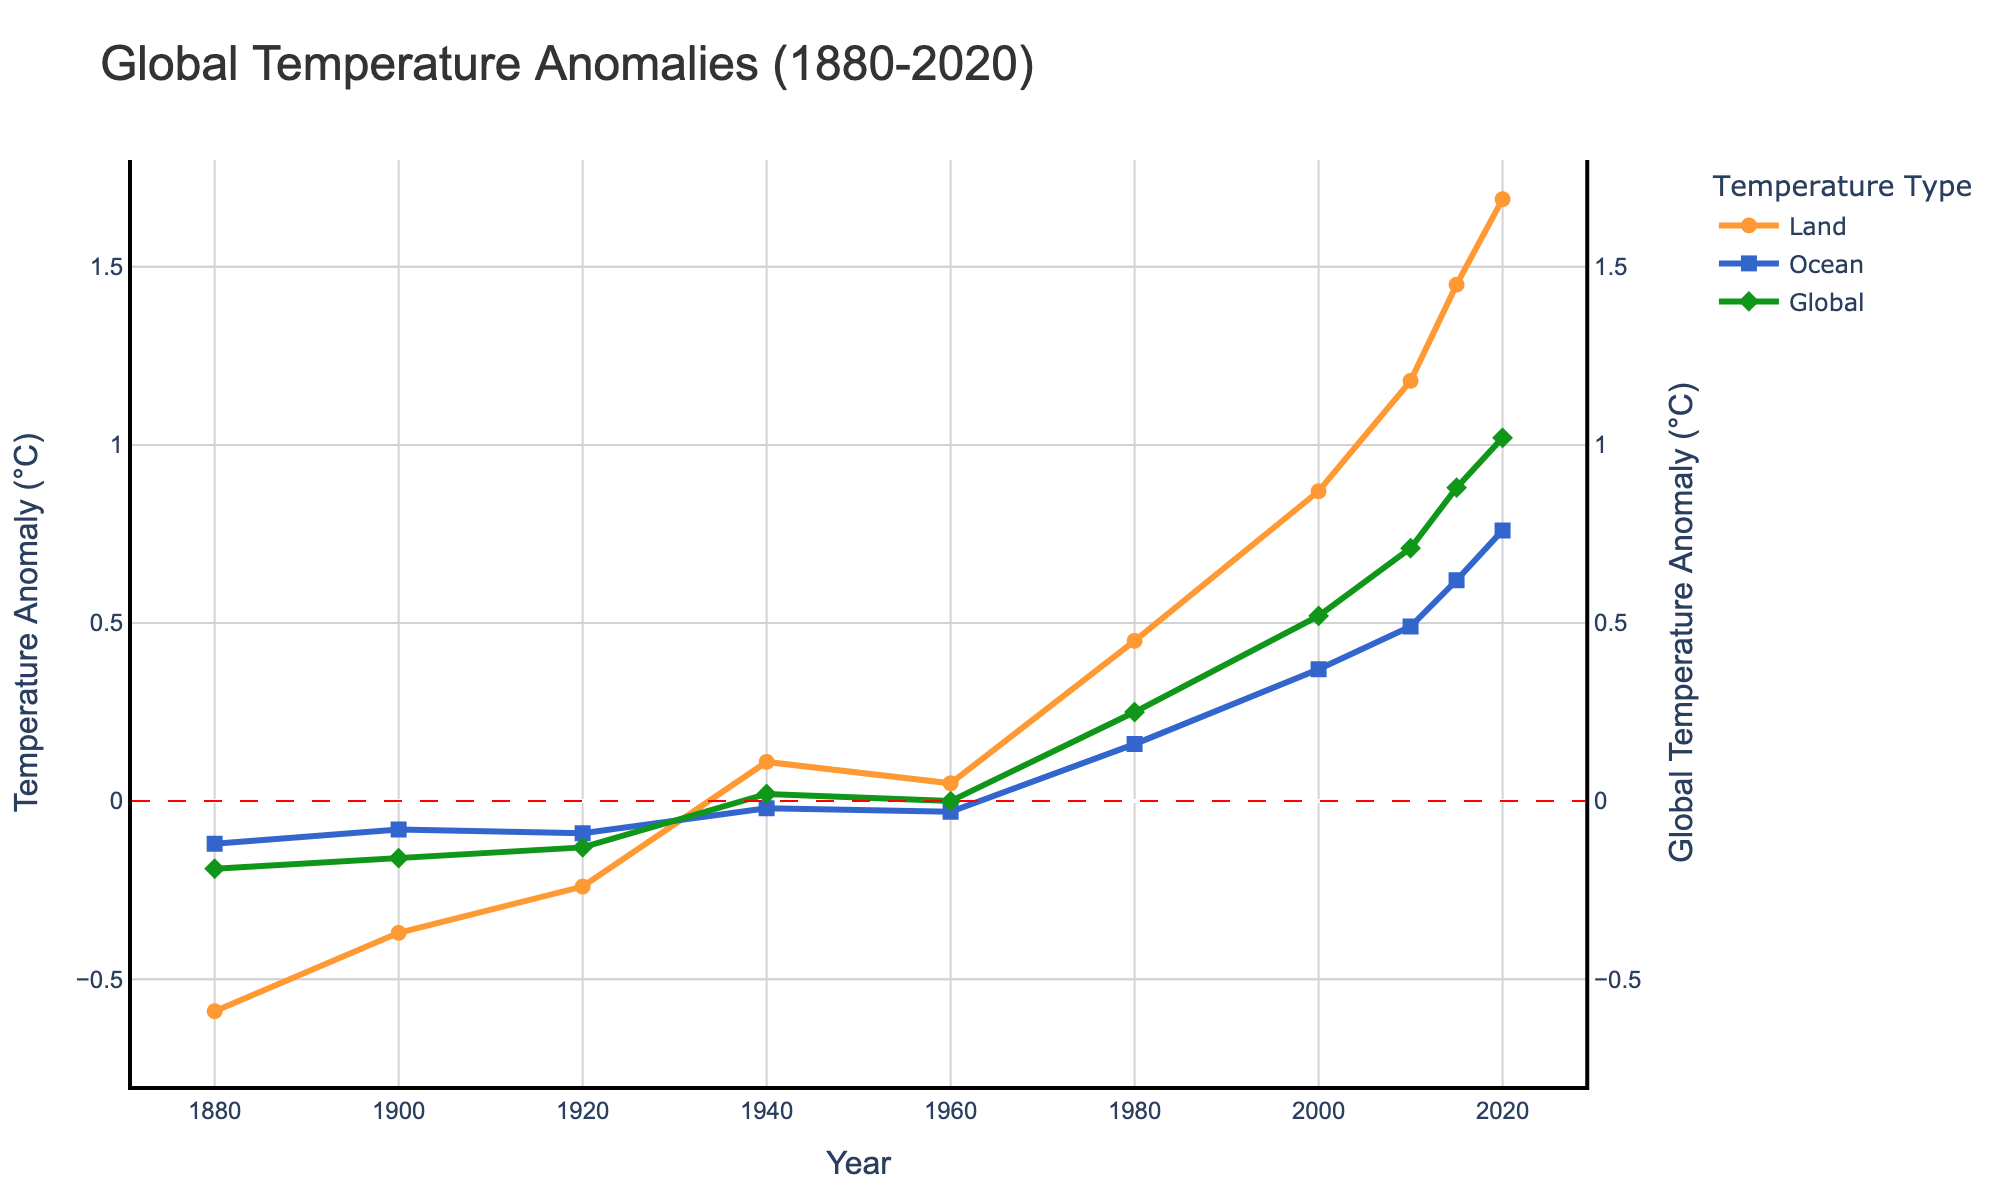What's the highest temperature anomaly recorded for land? The highest temperature anomaly for land can be found by looking at the peak of the orange line. From the figure, the land temperature anomaly in 2020 is 1.69°C.
Answer: 1.69°C How does the trend in ocean temperature anomalies compare to land temperature anomalies? By observing the blue and orange lines, one can notice that both land and ocean temperatures have been rising over time. However, the rate of increase and the anomalies are generally higher for land temperatures than for ocean temperatures.
Answer: Land temperatures rise faster What is the difference in the global temperature anomaly between 2000 and 2020? From the figure, the global temperature anomaly in 2000 is 0.52°C and in 2020 is 1.02°C. The difference is 1.02 - 0.52.
Answer: 0.50°C In which year was the ocean temperature anomaly closest to zero? By examining the blue line in the figure, the year when the ocean temperature anomaly is closest to zero is the year where the blue line intersects or is nearest to the zero line. This is observed around 1940.
Answer: 1940 Which temperature anomaly shows the most abrupt increase between two consecutive data points? The most abrupt increase can be identified by finding the steepest slope between two consecutive points. The orange line (land temperature) shows the steepest increase between 2010 and 2015.
Answer: Land temperature between 2010 and 2015 Did the ocean temperature anomaly ever exceed 0.7°C? By inspecting the blue line, it surpasses 0.7°C only once, near the end of the timeline in 2020.
Answer: Yes, in 2020 Which year recorded the lowest global temperature anomaly, and what was its value? The green line shows the global temperature anomaly, and by identifying the lowest dip in this line, one can see that it reaches its lowest point in 1880 at -0.19°C.
Answer: 1880; -0.19°C What is the average land temperature anomaly over the period displayed? To find the average, sum all the land temperature anomalies and divide by the number of data points: (-0.59 + (-0.37) + (-0.24) + 0.11 + 0.05 + 0.45 + 0.87 + 1.18 + 1.45 + 1.69) / 10 = 4.60 / 10 = 0.46.
Answer: 0.46°C Comparing 2000 and 2015, which segment (land or ocean) has a greater increase in temperature anomaly? For land: 1.45 - 0.87 = 0.58. For ocean: 0.62 - 0.37 = 0.25. The increase is greater for land temperatures.
Answer: Land segment By how much did the global temperature anomaly change from 1980 to 2010? Global temperature anomaly in 1980 was 0.25°C and in 2010 was 0.71°C. The change is 0.71 - 0.25 = 0.46.
Answer: 0.46°C 